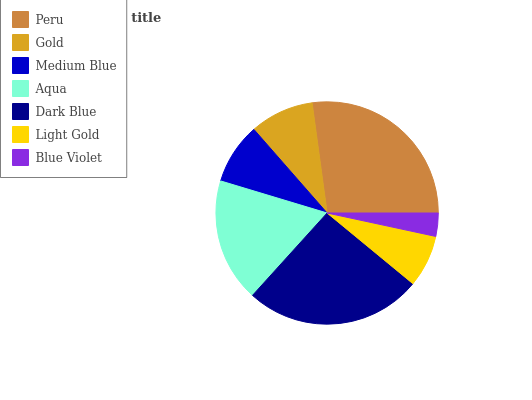Is Blue Violet the minimum?
Answer yes or no. Yes. Is Peru the maximum?
Answer yes or no. Yes. Is Gold the minimum?
Answer yes or no. No. Is Gold the maximum?
Answer yes or no. No. Is Peru greater than Gold?
Answer yes or no. Yes. Is Gold less than Peru?
Answer yes or no. Yes. Is Gold greater than Peru?
Answer yes or no. No. Is Peru less than Gold?
Answer yes or no. No. Is Gold the high median?
Answer yes or no. Yes. Is Gold the low median?
Answer yes or no. Yes. Is Aqua the high median?
Answer yes or no. No. Is Medium Blue the low median?
Answer yes or no. No. 